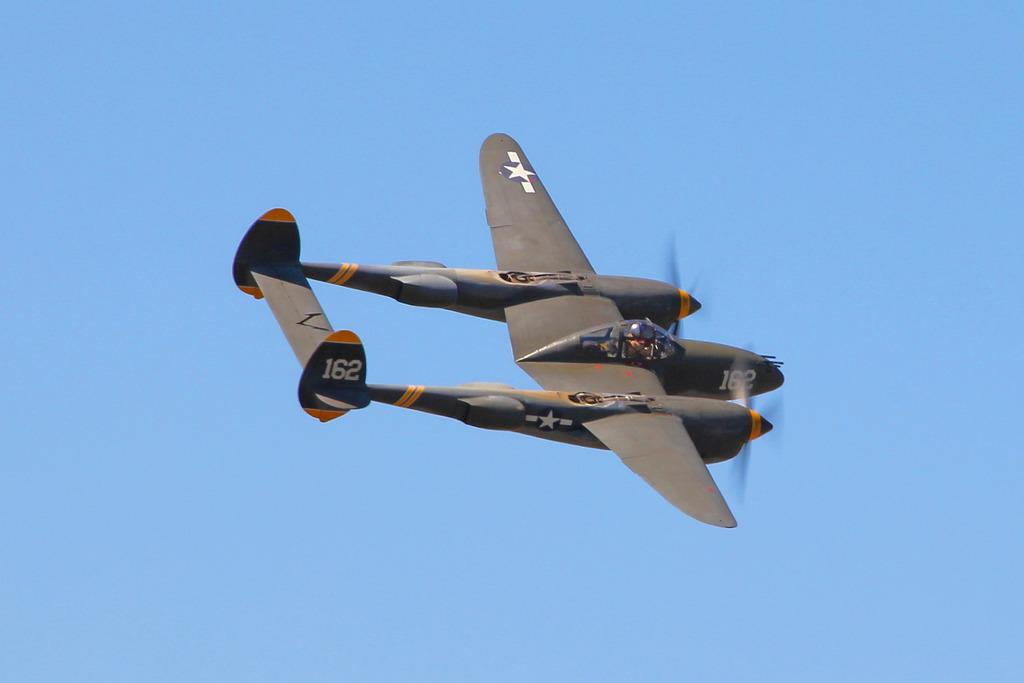What is the main subject of the image? The main subject of the image is an aircraft. What is the aircraft doing in the image? The aircraft is flying in the sky. What song is being played by the aircraft in the image? There is no indication in the image that the aircraft is playing a song. 